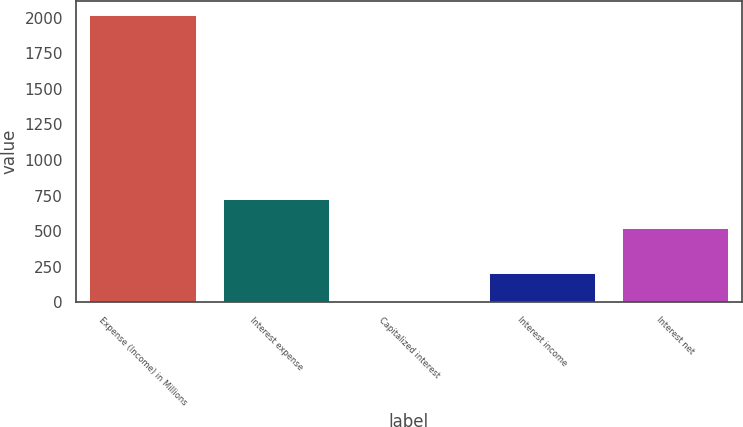<chart> <loc_0><loc_0><loc_500><loc_500><bar_chart><fcel>Expense (Income) in Millions<fcel>Interest expense<fcel>Capitalized interest<fcel>Interest income<fcel>Interest net<nl><fcel>2019<fcel>723.42<fcel>2.8<fcel>204.42<fcel>521.8<nl></chart> 